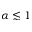Convert formula to latex. <formula><loc_0><loc_0><loc_500><loc_500>\alpha \lesssim 1</formula> 